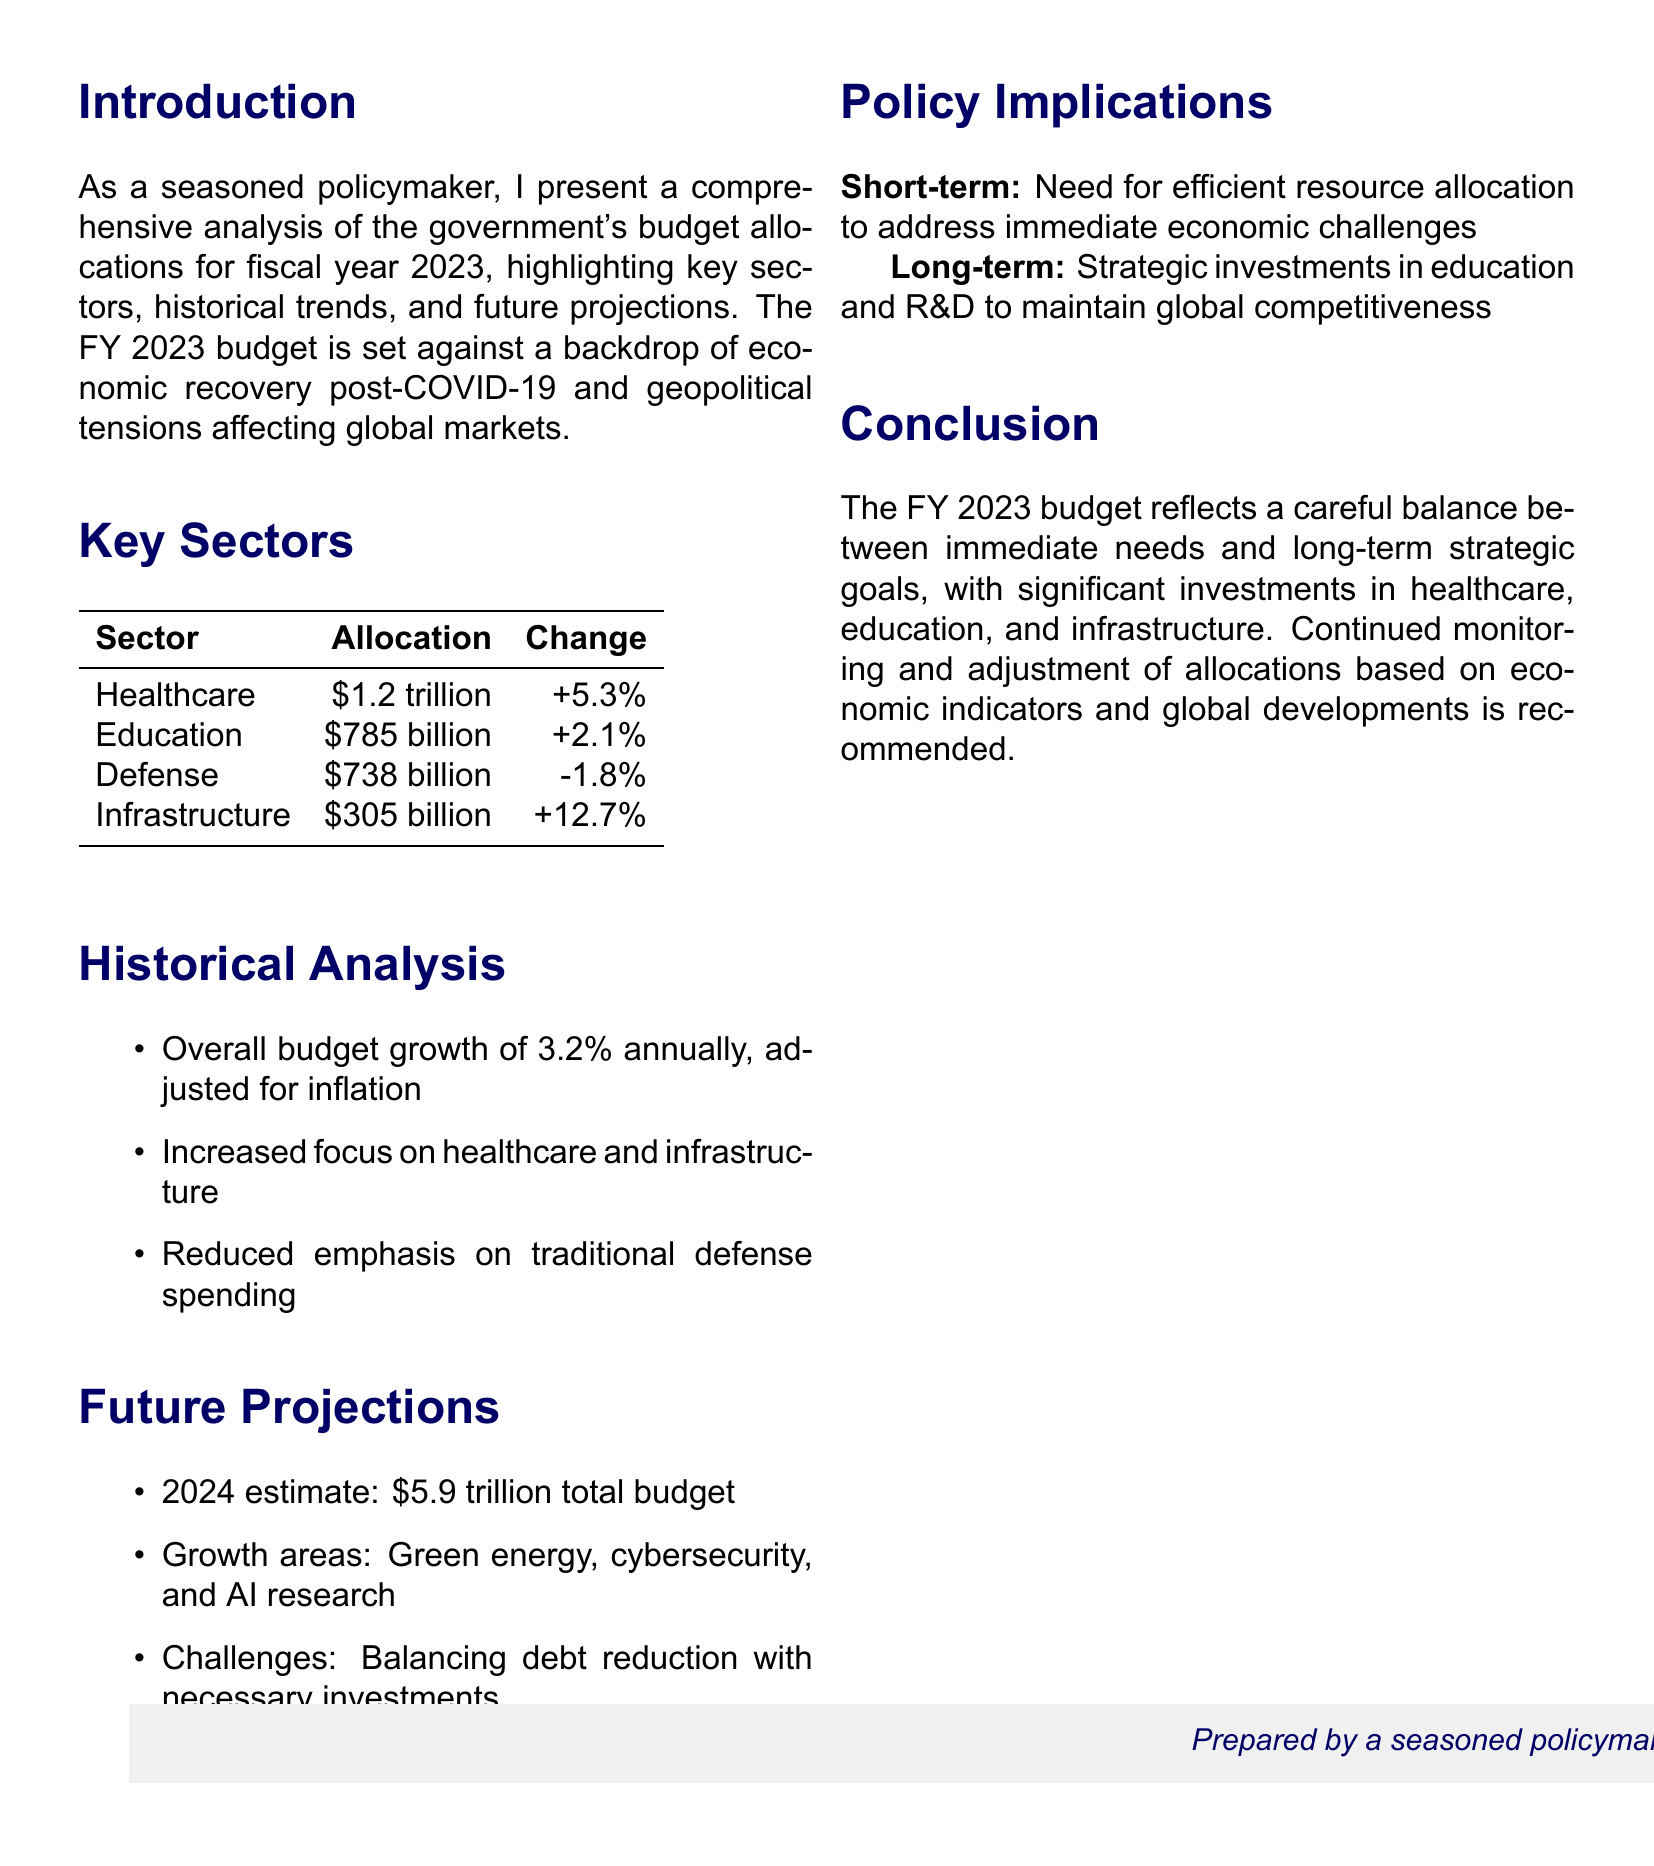What is the total allocation for Healthcare? The total allocation for Healthcare is specifically stated in the document as $1.2 trillion.
Answer: $1.2 trillion What is the percentage change in allocation for Defense from FY 2022? The document states that the change in allocation for Defense is -1.8% from FY 2022.
Answer: -1.8% What is the historical budget growth rate adjusted for inflation? The overall budget growth of 3.2% annually, adjusted for inflation, is mentioned in the historical analysis section.
Answer: 3.2% Which sector has the largest increase in budget allocation for FY 2023? The document identifies Infrastructure with a +12.7% increase as the largest increase.
Answer: Infrastructure What is the estimated total budget for 2024? The document provides a future projection of the total budget for 2024 as $5.9 trillion.
Answer: $5.9 trillion What areas are projected for growth in future budgets? The document indicates that growth areas include green energy, cybersecurity, and artificial intelligence research.
Answer: Green energy, cybersecurity, AI research What does the short-term policy implication emphasize? The short-term policy implication emphasizes the need for efficient resource allocation to address immediate economic challenges.
Answer: Efficient resource allocation What is the main reason for the significant investment in Healthcare? The document connects the steady increase in Healthcare spending to the impact of the pandemic.
Answer: Pandemic What is the recommendation provided in the conclusion? The document recommends continued monitoring and adjustment of allocations based on economic indicators and global developments.
Answer: Continued monitoring and adjustment 